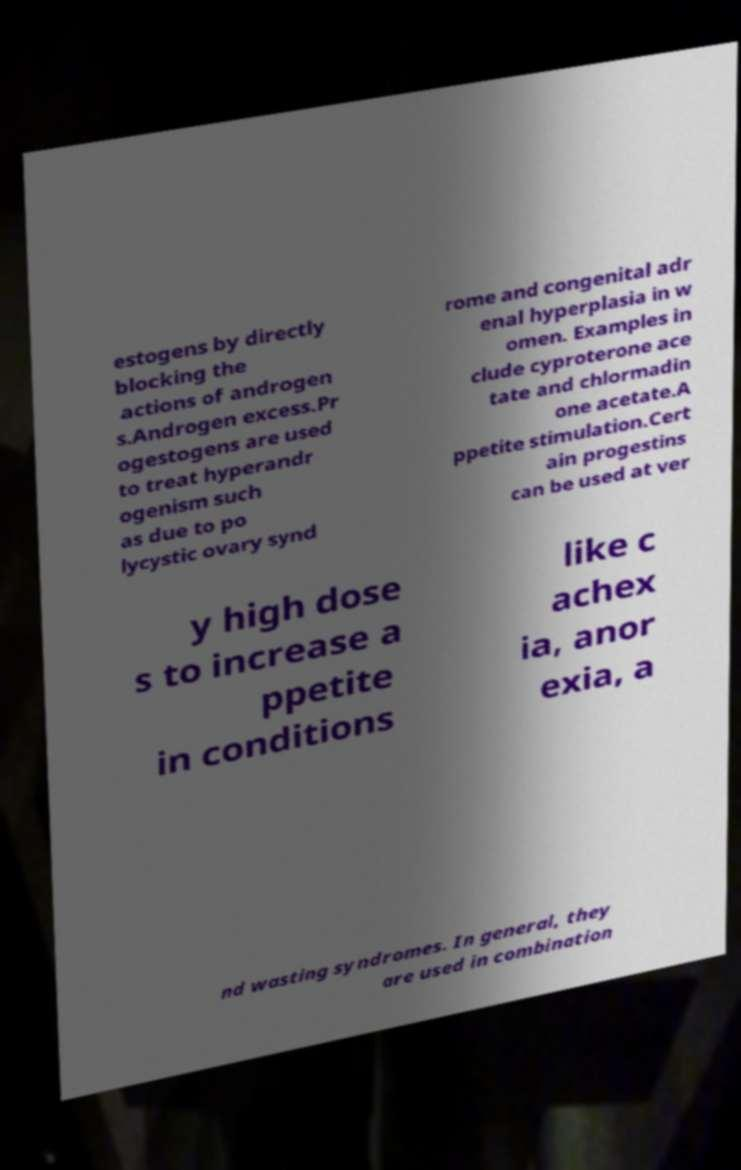Please identify and transcribe the text found in this image. estogens by directly blocking the actions of androgen s.Androgen excess.Pr ogestogens are used to treat hyperandr ogenism such as due to po lycystic ovary synd rome and congenital adr enal hyperplasia in w omen. Examples in clude cyproterone ace tate and chlormadin one acetate.A ppetite stimulation.Cert ain progestins can be used at ver y high dose s to increase a ppetite in conditions like c achex ia, anor exia, a nd wasting syndromes. In general, they are used in combination 